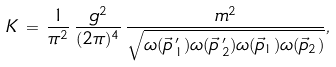<formula> <loc_0><loc_0><loc_500><loc_500>K \, = \, \frac { 1 } { \pi ^ { 2 } } \, \frac { g ^ { 2 } } { ( 2 \pi ) ^ { 4 } } \, \frac { m ^ { 2 } } { \sqrt { \omega ( \vec { p } \, ^ { \prime } _ { 1 } ) \omega ( \vec { p } \, ^ { \prime } _ { 2 } ) \omega ( \vec { p } _ { 1 } ) \omega ( \vec { p } _ { 2 } ) } } ,</formula> 